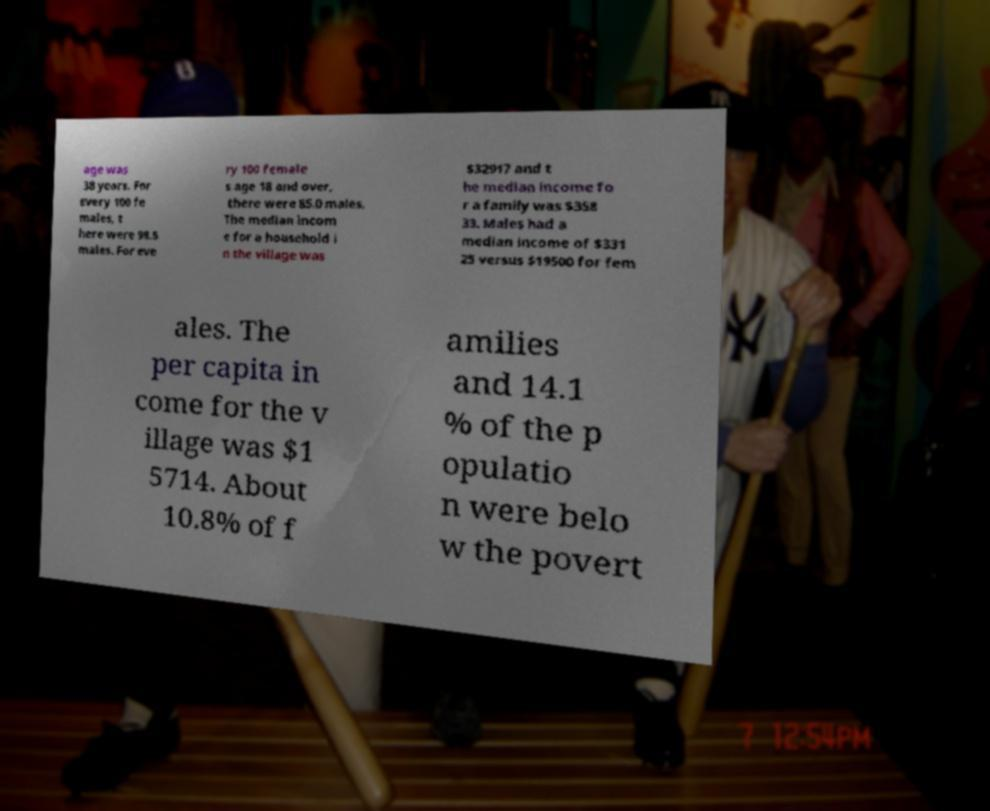For documentation purposes, I need the text within this image transcribed. Could you provide that? age was 38 years. For every 100 fe males, t here were 98.5 males. For eve ry 100 female s age 18 and over, there were 85.0 males. The median incom e for a household i n the village was $32917 and t he median income fo r a family was $358 33. Males had a median income of $331 25 versus $19500 for fem ales. The per capita in come for the v illage was $1 5714. About 10.8% of f amilies and 14.1 % of the p opulatio n were belo w the povert 